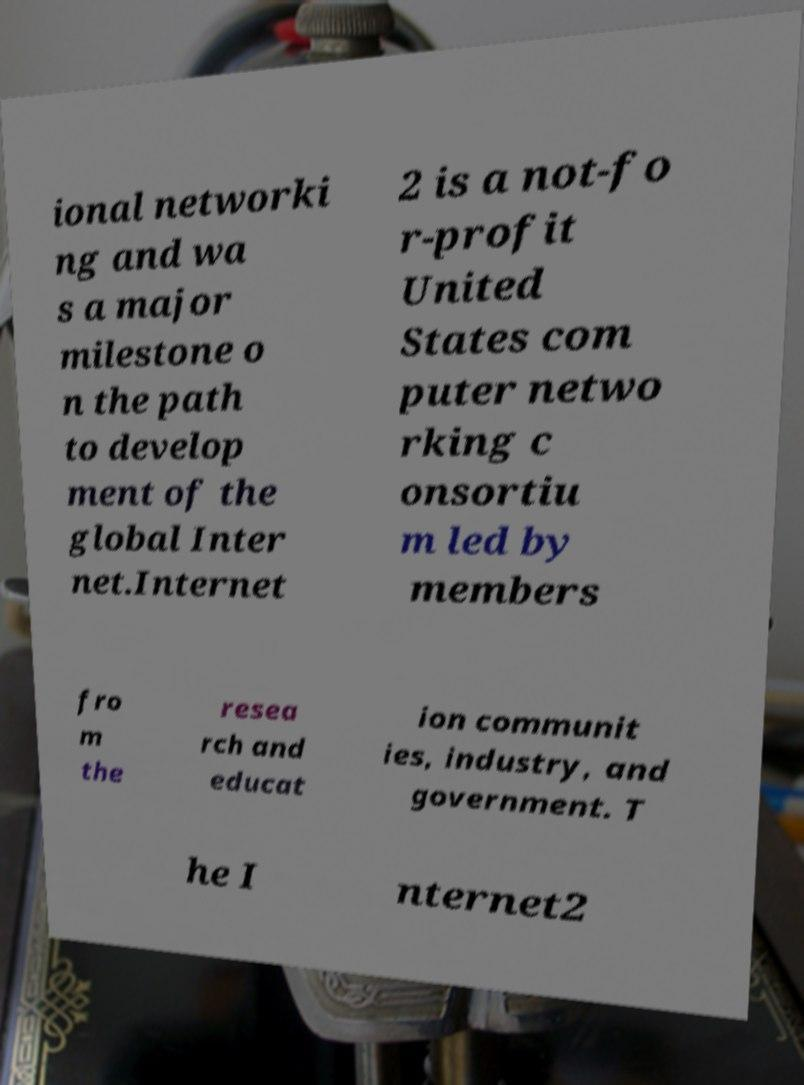Could you assist in decoding the text presented in this image and type it out clearly? ional networki ng and wa s a major milestone o n the path to develop ment of the global Inter net.Internet 2 is a not-fo r-profit United States com puter netwo rking c onsortiu m led by members fro m the resea rch and educat ion communit ies, industry, and government. T he I nternet2 